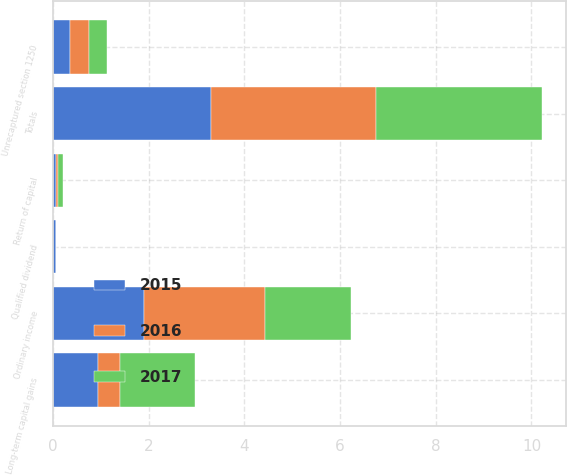Convert chart. <chart><loc_0><loc_0><loc_500><loc_500><stacked_bar_chart><ecel><fcel>Ordinary income<fcel>Qualified dividend<fcel>Return of capital<fcel>Long-term capital gains<fcel>Unrecaptured section 1250<fcel>Totals<nl><fcel>2017<fcel>1.81<fcel>0<fcel>0.09<fcel>1.57<fcel>0.36<fcel>3.48<nl><fcel>2016<fcel>2.51<fcel>0<fcel>0.06<fcel>0.46<fcel>0.41<fcel>3.44<nl><fcel>2015<fcel>1.91<fcel>0.05<fcel>0.05<fcel>0.94<fcel>0.35<fcel>3.3<nl></chart> 